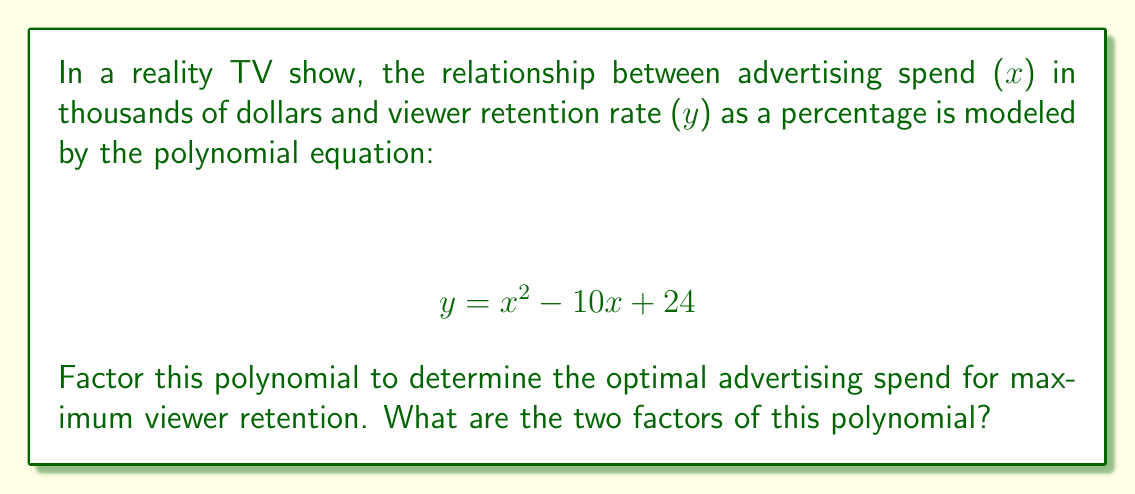Solve this math problem. To factor this quadratic polynomial, we'll follow these steps:

1) First, identify the coefficients:
   $a = 1$, $b = -10$, and $c = 24$

2) We need to find two numbers that multiply to give $ac = 1 \times 24 = 24$ and add up to $b = -10$

3) The numbers that satisfy this are $-6$ and $-4$

4) Rewrite the middle term using these numbers:
   $$ y = x^2 - 6x - 4x + 24 $$

5) Group the terms:
   $$ y = (x^2 - 6x) + (-4x + 24) $$

6) Factor out the common factors from each group:
   $$ y = x(x - 6) - 4(x - 6) $$

7) Factor out the common binomial $(x - 6)$:
   $$ y = (x - 6)(x - 4) $$

This factored form reveals that the optimal advertising spend for maximum viewer retention would be at $x = 6$ or $x = 4$ thousand dollars, as these are the roots of the polynomial where the curve crosses the x-axis.
Answer: $(x - 6)(x - 4)$ 